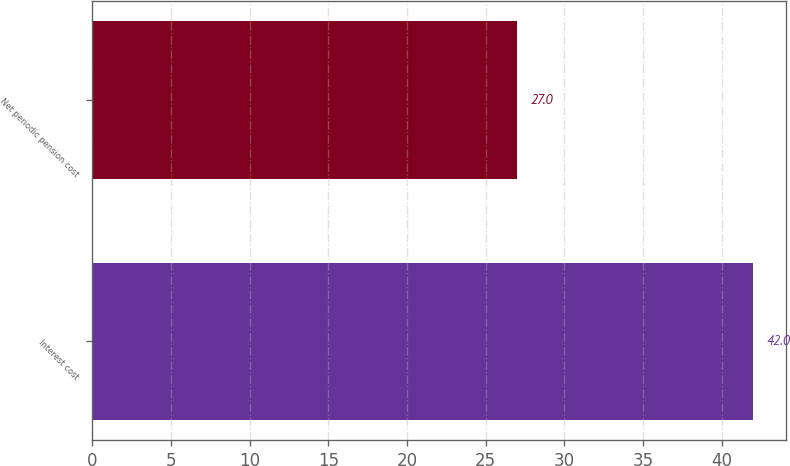Convert chart to OTSL. <chart><loc_0><loc_0><loc_500><loc_500><bar_chart><fcel>Interest cost<fcel>Net periodic pension cost<nl><fcel>42<fcel>27<nl></chart> 